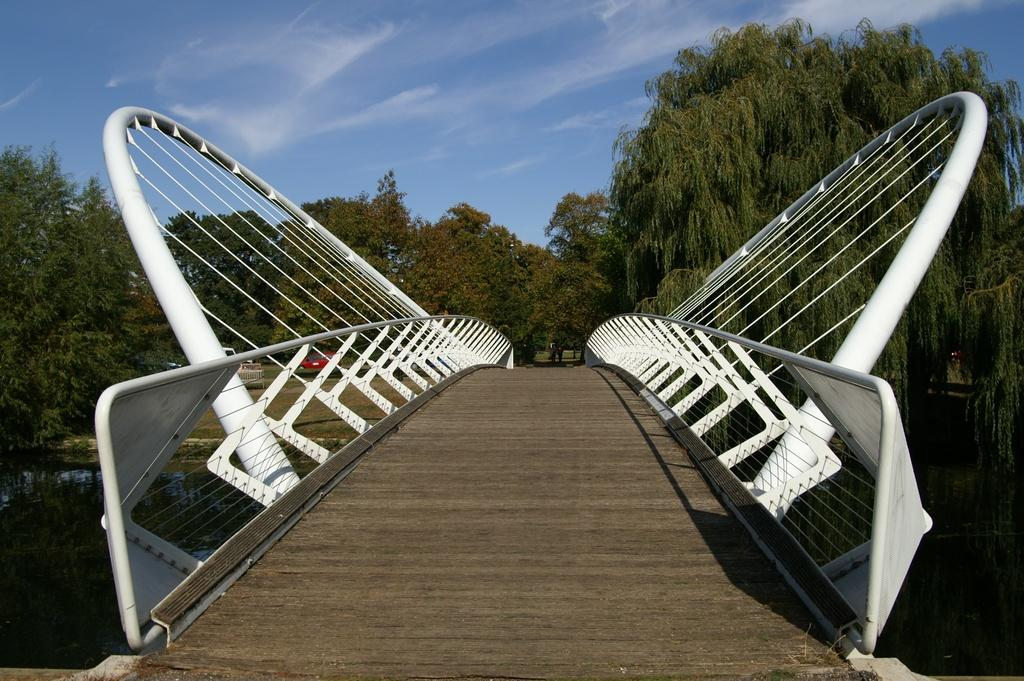What structure is the main subject of the image? There is a bridge in the image. What is the bridge positioned over? The bridge is over water. What can be seen in the background of the image? There are vehicles and trees visible in the background, as well as the sky. What type of magic is being performed on the bridge in the image? There is no magic or any indication of magic being performed in the image; it simply shows a bridge over water. What educational institution is visible in the image? There is no educational institution present in the image; it features a bridge over water with vehicles and trees in the background. 